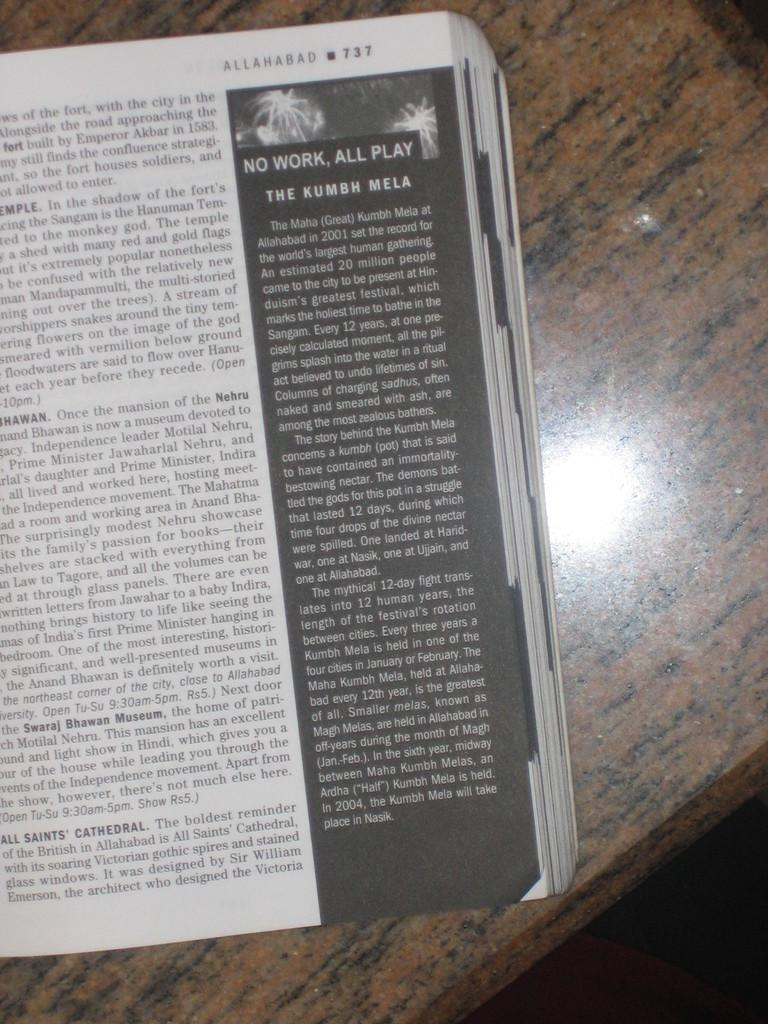<image>
Provide a brief description of the given image. An book opened to a page that says Allahbad 737 at the corner right top of the page. 